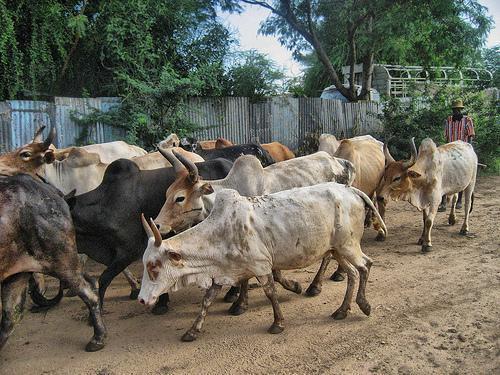How many men are in the picture?
Give a very brief answer. 1. 